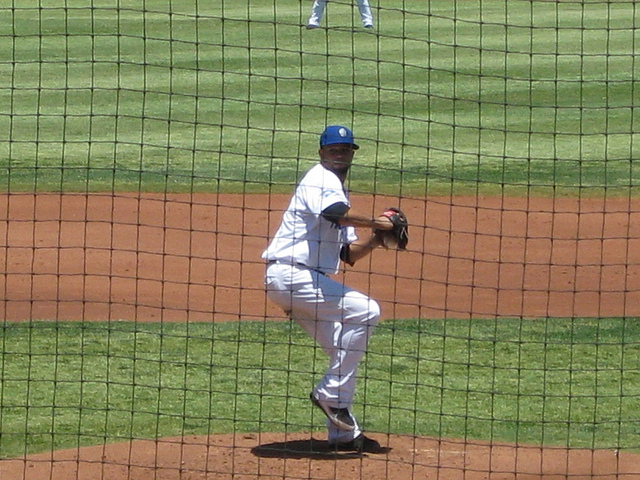<image>What number of squares make up the mesh behind the catcher? It is ambiguous how many squares make up the mesh. Numbers range from 100 up to 2000. What number of squares make up the mesh behind the catcher? I don't know what number of squares make up the mesh behind the catcher. 